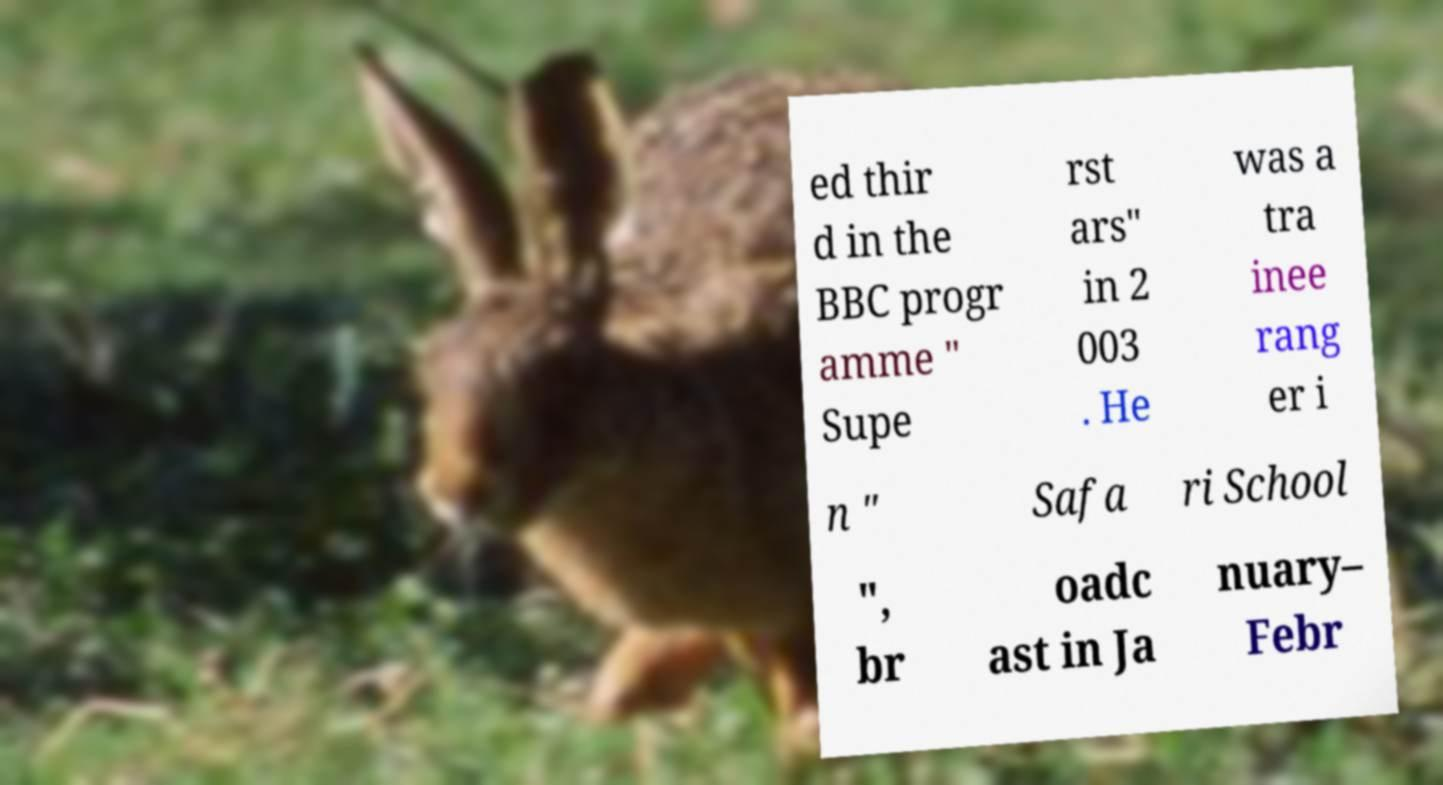Please identify and transcribe the text found in this image. ed thir d in the BBC progr amme " Supe rst ars" in 2 003 . He was a tra inee rang er i n " Safa ri School ", br oadc ast in Ja nuary– Febr 